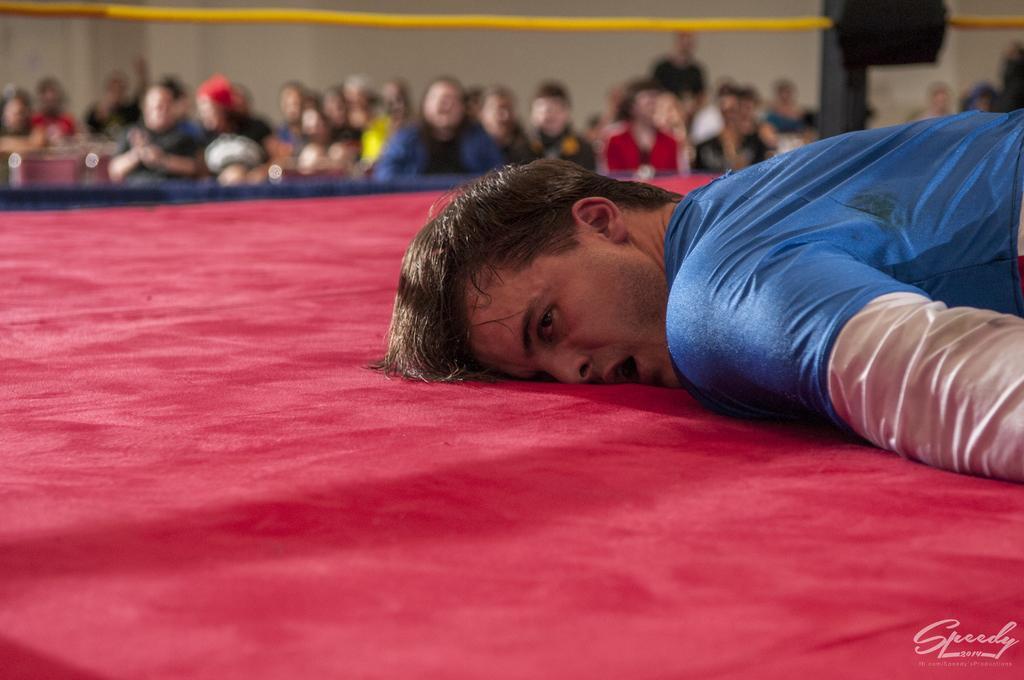Describe this image in one or two sentences. In this image there is a person lying on a stage, in the background there are people standing and it is blurred. 